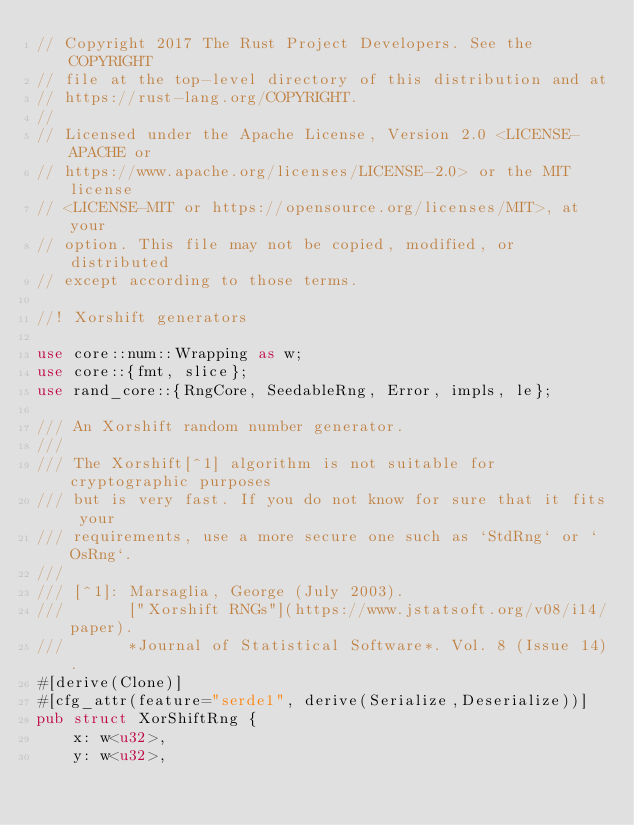Convert code to text. <code><loc_0><loc_0><loc_500><loc_500><_Rust_>// Copyright 2017 The Rust Project Developers. See the COPYRIGHT
// file at the top-level directory of this distribution and at
// https://rust-lang.org/COPYRIGHT.
//
// Licensed under the Apache License, Version 2.0 <LICENSE-APACHE or
// https://www.apache.org/licenses/LICENSE-2.0> or the MIT license
// <LICENSE-MIT or https://opensource.org/licenses/MIT>, at your
// option. This file may not be copied, modified, or distributed
// except according to those terms.

//! Xorshift generators

use core::num::Wrapping as w;
use core::{fmt, slice};
use rand_core::{RngCore, SeedableRng, Error, impls, le};

/// An Xorshift random number generator.
///
/// The Xorshift[^1] algorithm is not suitable for cryptographic purposes
/// but is very fast. If you do not know for sure that it fits your
/// requirements, use a more secure one such as `StdRng` or `OsRng`.
///
/// [^1]: Marsaglia, George (July 2003).
///       ["Xorshift RNGs"](https://www.jstatsoft.org/v08/i14/paper).
///       *Journal of Statistical Software*. Vol. 8 (Issue 14).
#[derive(Clone)]
#[cfg_attr(feature="serde1", derive(Serialize,Deserialize))]
pub struct XorShiftRng {
    x: w<u32>,
    y: w<u32>,</code> 